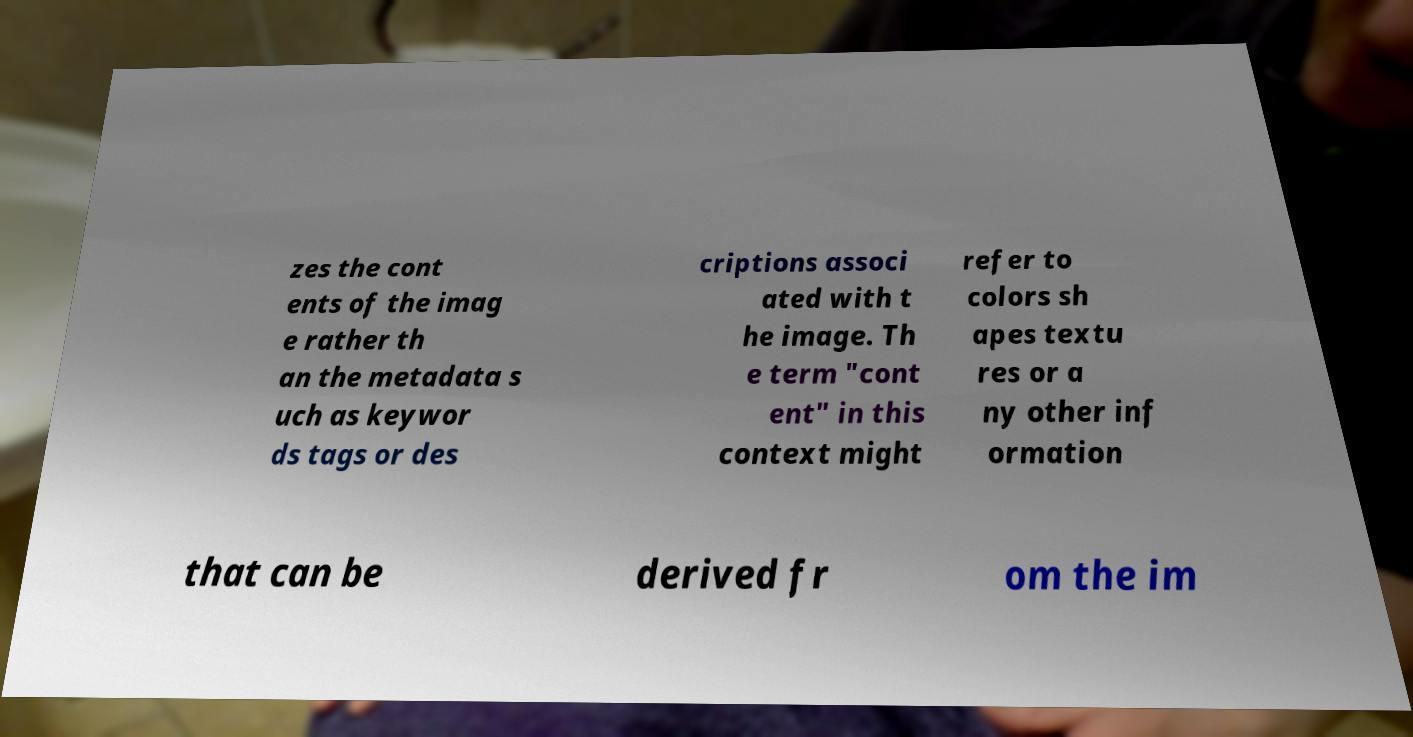There's text embedded in this image that I need extracted. Can you transcribe it verbatim? zes the cont ents of the imag e rather th an the metadata s uch as keywor ds tags or des criptions associ ated with t he image. Th e term "cont ent" in this context might refer to colors sh apes textu res or a ny other inf ormation that can be derived fr om the im 